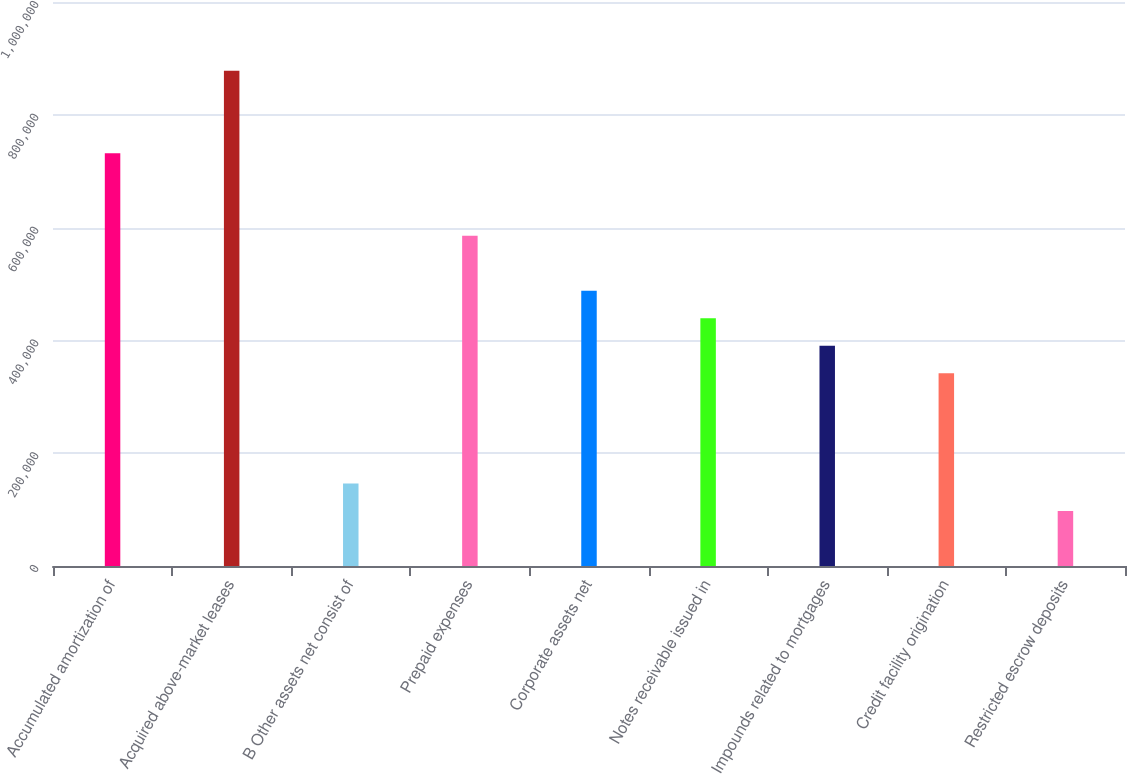Convert chart. <chart><loc_0><loc_0><loc_500><loc_500><bar_chart><fcel>Accumulated amortization of<fcel>Acquired above-market leases<fcel>B Other assets net consist of<fcel>Prepaid expenses<fcel>Corporate assets net<fcel>Notes receivable issued in<fcel>Impounds related to mortgages<fcel>Credit facility origination<fcel>Restricted escrow deposits<nl><fcel>731856<fcel>878211<fcel>146440<fcel>585502<fcel>487933<fcel>439148<fcel>390364<fcel>341579<fcel>97655.4<nl></chart> 